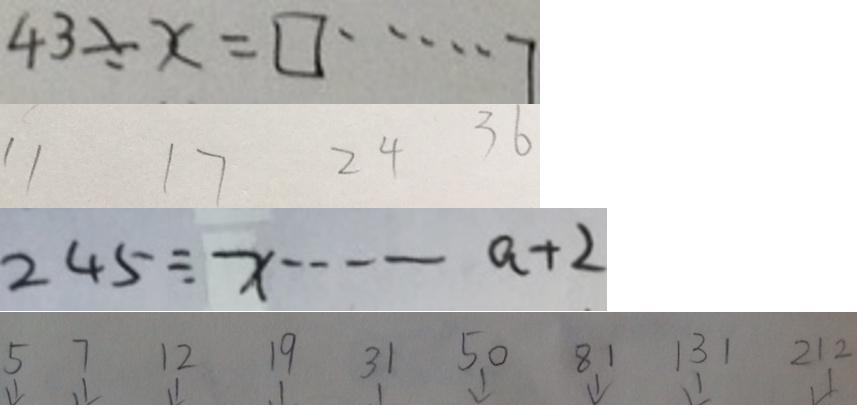<formula> <loc_0><loc_0><loc_500><loc_500>4 3 \div x = \square \cdots 7 
 1 1 1 7 2 4 3 6 
 2 4 5 \div x \cdots a + 2 
 5 7 1 2 1 9 3 1 5 0 8 1 1 3 1 2 1 2</formula> 